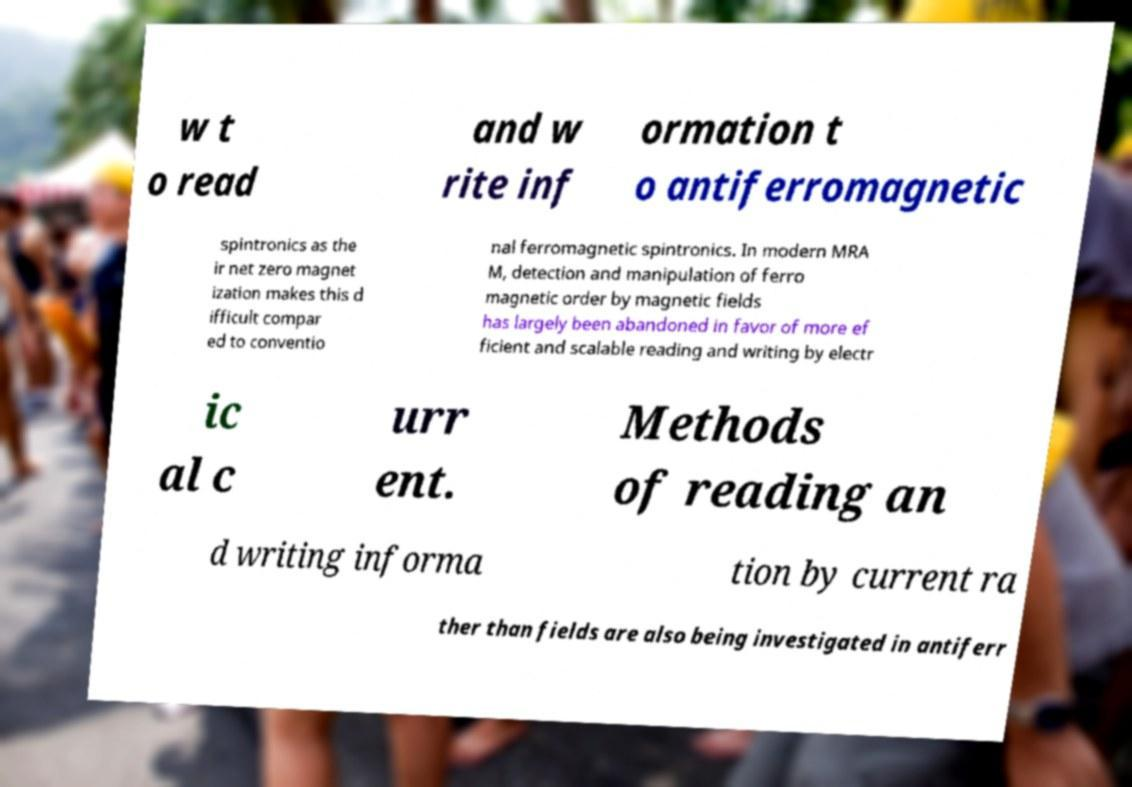Can you read and provide the text displayed in the image?This photo seems to have some interesting text. Can you extract and type it out for me? w t o read and w rite inf ormation t o antiferromagnetic spintronics as the ir net zero magnet ization makes this d ifficult compar ed to conventio nal ferromagnetic spintronics. In modern MRA M, detection and manipulation of ferro magnetic order by magnetic fields has largely been abandoned in favor of more ef ficient and scalable reading and writing by electr ic al c urr ent. Methods of reading an d writing informa tion by current ra ther than fields are also being investigated in antiferr 